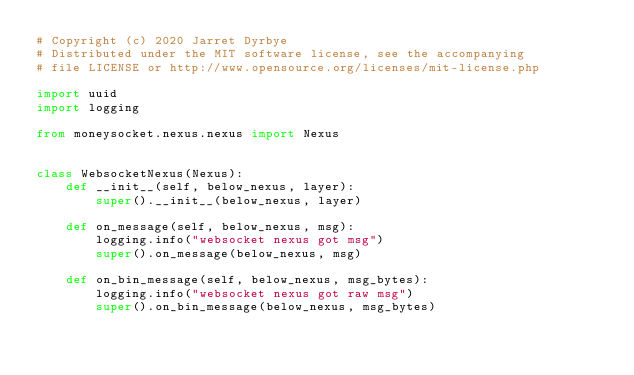<code> <loc_0><loc_0><loc_500><loc_500><_Python_># Copyright (c) 2020 Jarret Dyrbye
# Distributed under the MIT software license, see the accompanying
# file LICENSE or http://www.opensource.org/licenses/mit-license.php

import uuid
import logging

from moneysocket.nexus.nexus import Nexus


class WebsocketNexus(Nexus):
    def __init__(self, below_nexus, layer):
        super().__init__(below_nexus, layer)

    def on_message(self, below_nexus, msg):
        logging.info("websocket nexus got msg")
        super().on_message(below_nexus, msg)

    def on_bin_message(self, below_nexus, msg_bytes):
        logging.info("websocket nexus got raw msg")
        super().on_bin_message(below_nexus, msg_bytes)
</code> 